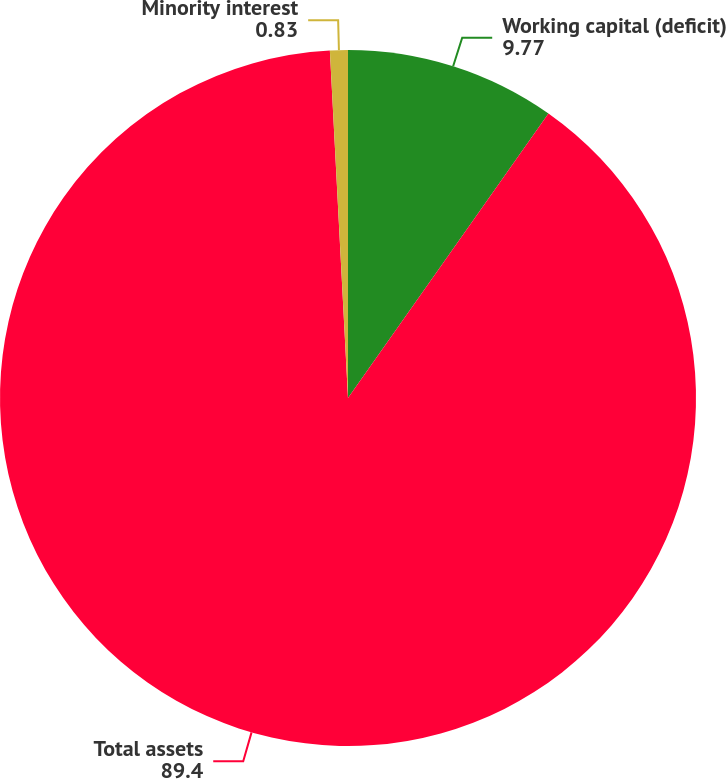Convert chart. <chart><loc_0><loc_0><loc_500><loc_500><pie_chart><fcel>Working capital (deficit)<fcel>Total assets<fcel>Minority interest<nl><fcel>9.77%<fcel>89.4%<fcel>0.83%<nl></chart> 